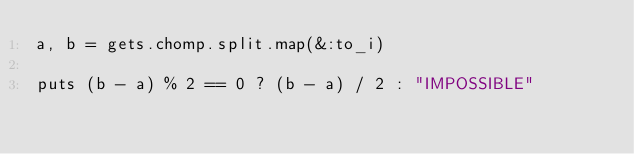Convert code to text. <code><loc_0><loc_0><loc_500><loc_500><_Ruby_>a, b = gets.chomp.split.map(&:to_i)

puts (b - a) % 2 == 0 ? (b - a) / 2 : "IMPOSSIBLE"
</code> 